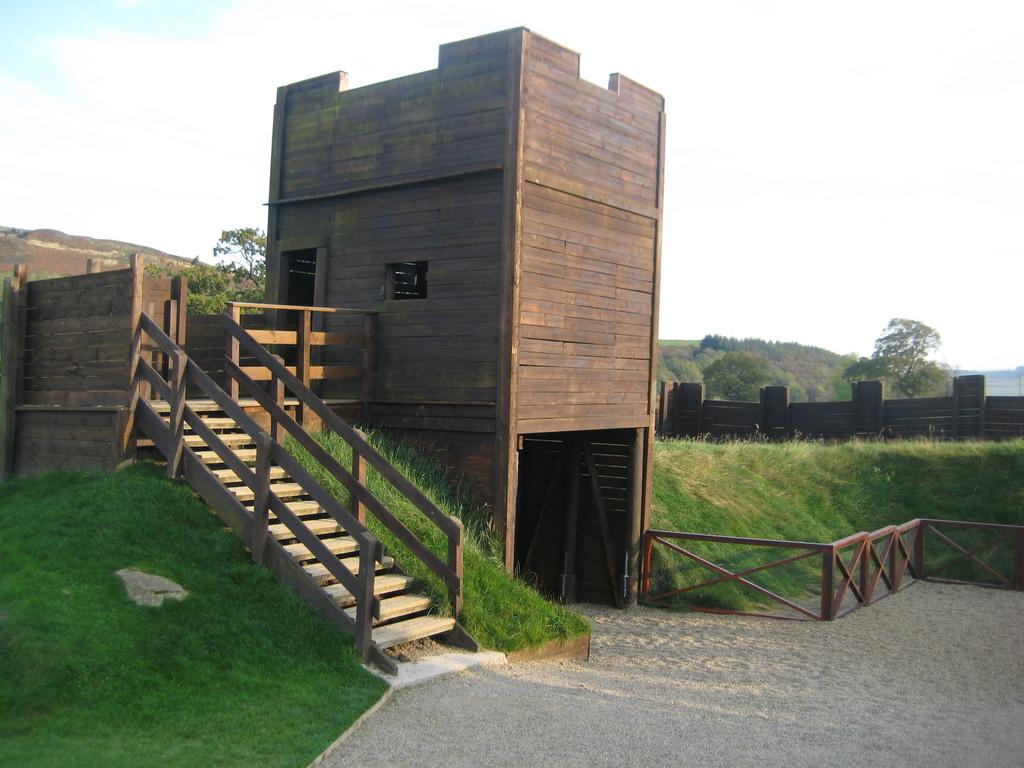What type of structure is present in the image? There is a building in the image. What is the architectural feature that allows movement between different levels? There is a staircase in the image. What type of vegetation can be seen in the middle of the image? Grass is visible in the middle of the image. What is visible in the background of the image? The sky is visible in the background of the image. What type of barrier is present in the middle of the image? There is a fence visible in the middle of the image. How many oranges are stacked in the crate in the image? There is no crate or oranges present in the image. What type of boundary is created by the oranges in the image? There are no oranges or boundaries created by them in the image. 